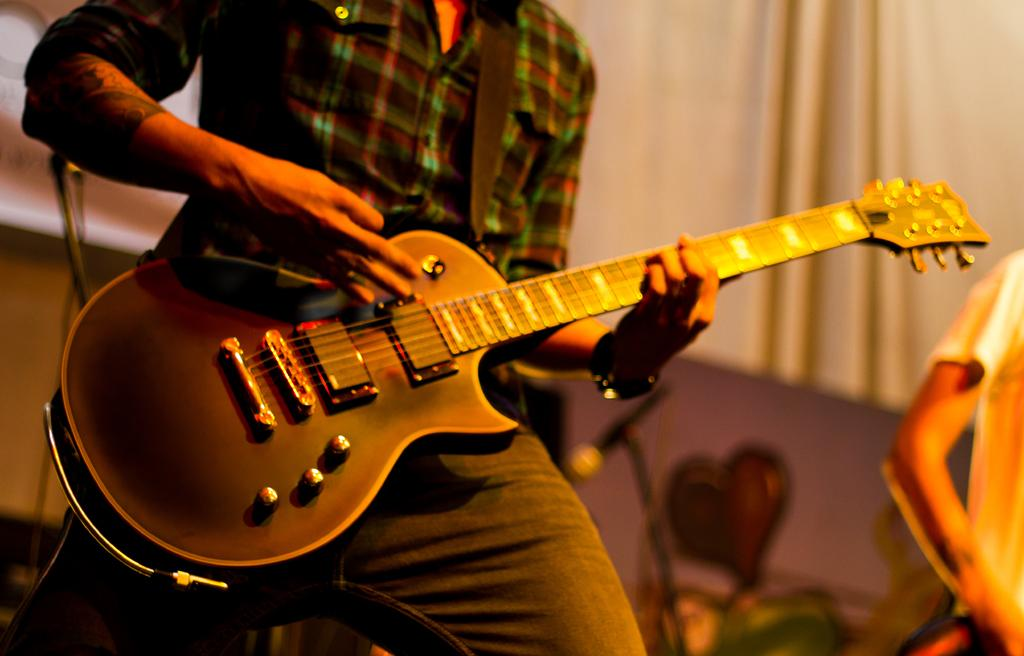What is the main subject of the image? The main subject of the image is a man. What is the man holding in his hand? The man is holding a guitar in his hand. What type of apparel does the man regret wearing in the image? There is no indication in the image that the man is wearing any apparel, nor is there any mention of regret. 